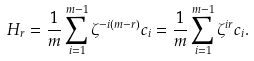Convert formula to latex. <formula><loc_0><loc_0><loc_500><loc_500>H _ { r } = \frac { 1 } { m } \sum _ { i = 1 } ^ { m - 1 } \zeta ^ { - i ( m - r ) } c _ { i } = \frac { 1 } { m } \sum _ { i = 1 } ^ { m - 1 } \zeta ^ { i r } c _ { i } .</formula> 